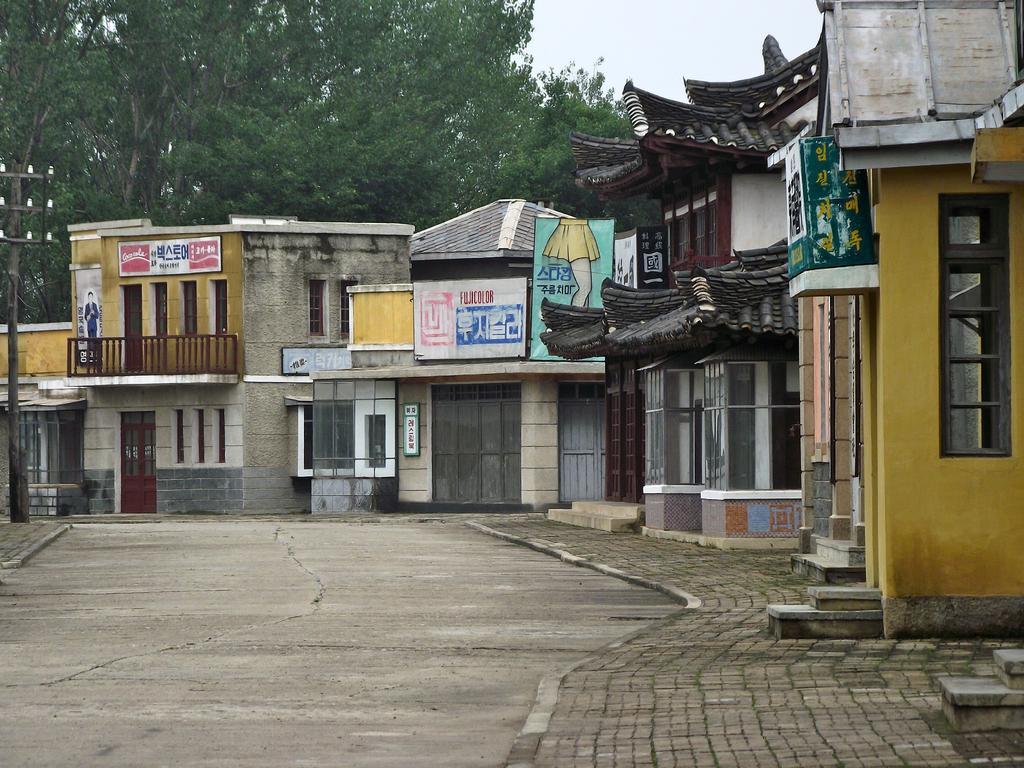Could you give a brief overview of what you see in this image? In this image we can see buildings, doors, windows, name boards on the wall, trees, poles and clouds in the sky. At the bottom we can see the road. 